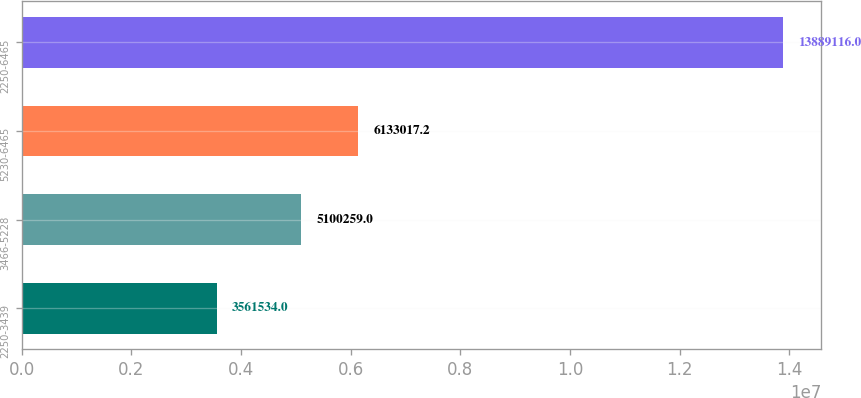Convert chart to OTSL. <chart><loc_0><loc_0><loc_500><loc_500><bar_chart><fcel>2250-3439<fcel>3466-5228<fcel>5230-6465<fcel>2250-6465<nl><fcel>3.56153e+06<fcel>5.10026e+06<fcel>6.13302e+06<fcel>1.38891e+07<nl></chart> 